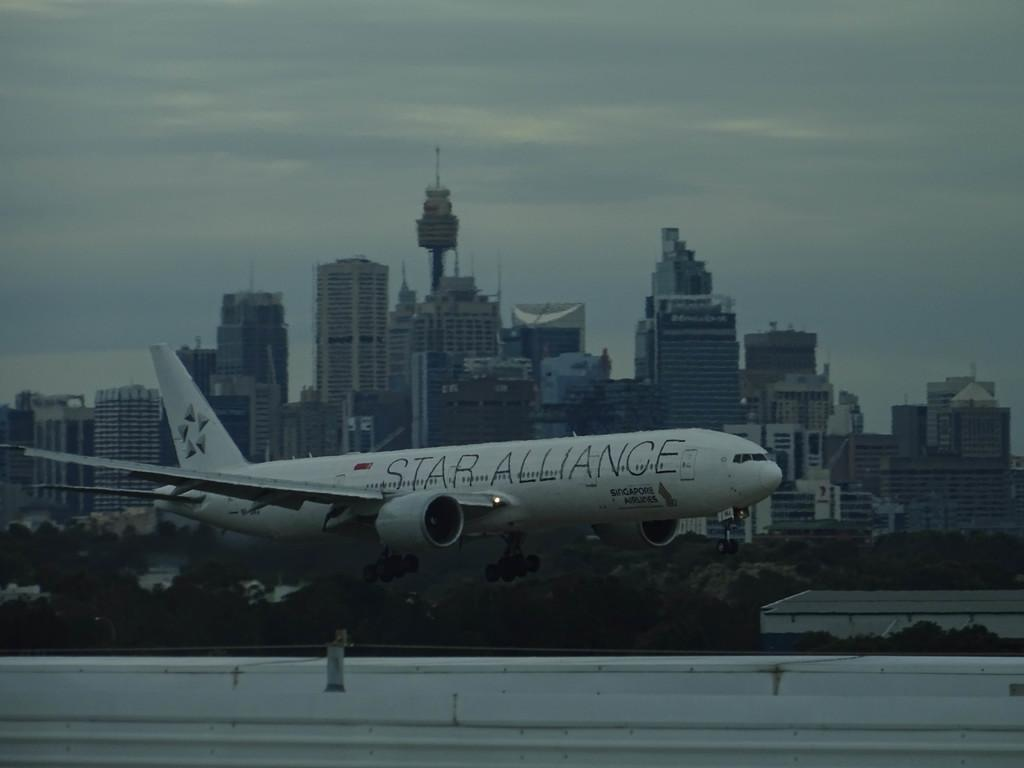What type of structures can be seen in the image? There are buildings in the image. What other natural elements are present in the image? There are trees in the image. Is there any transportation visible in the image? Yes, there is an aeroplane in the image. What is the color of the aeroplane? The aeroplane is white in color. What can be seen in the background of the image? The sky is visible in the image. What colors are present in the sky? The sky has a white and blue color. Can you tell me how many wishes are granted in the image? There is no mention of wishes or any related activity in the image. Is there any sea visible in the image? There is no sea present in the image; it features buildings, trees, an aeroplane, and the sky. 